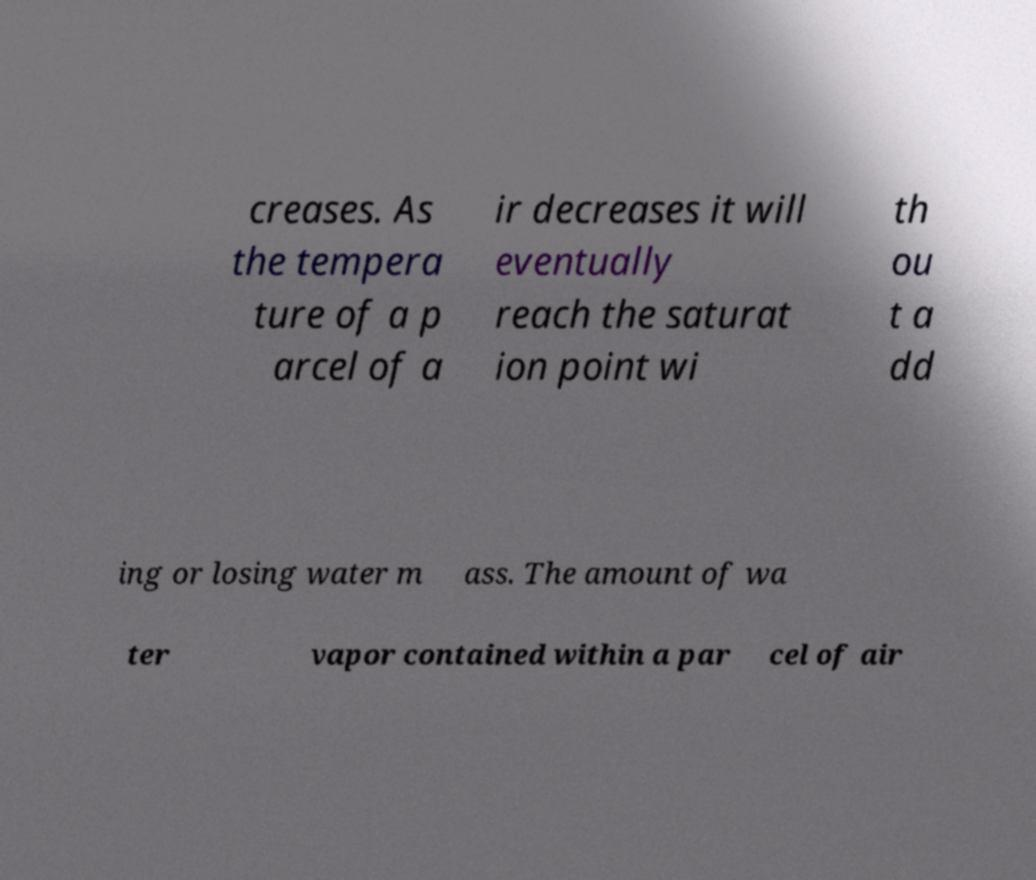Please read and relay the text visible in this image. What does it say? creases. As the tempera ture of a p arcel of a ir decreases it will eventually reach the saturat ion point wi th ou t a dd ing or losing water m ass. The amount of wa ter vapor contained within a par cel of air 